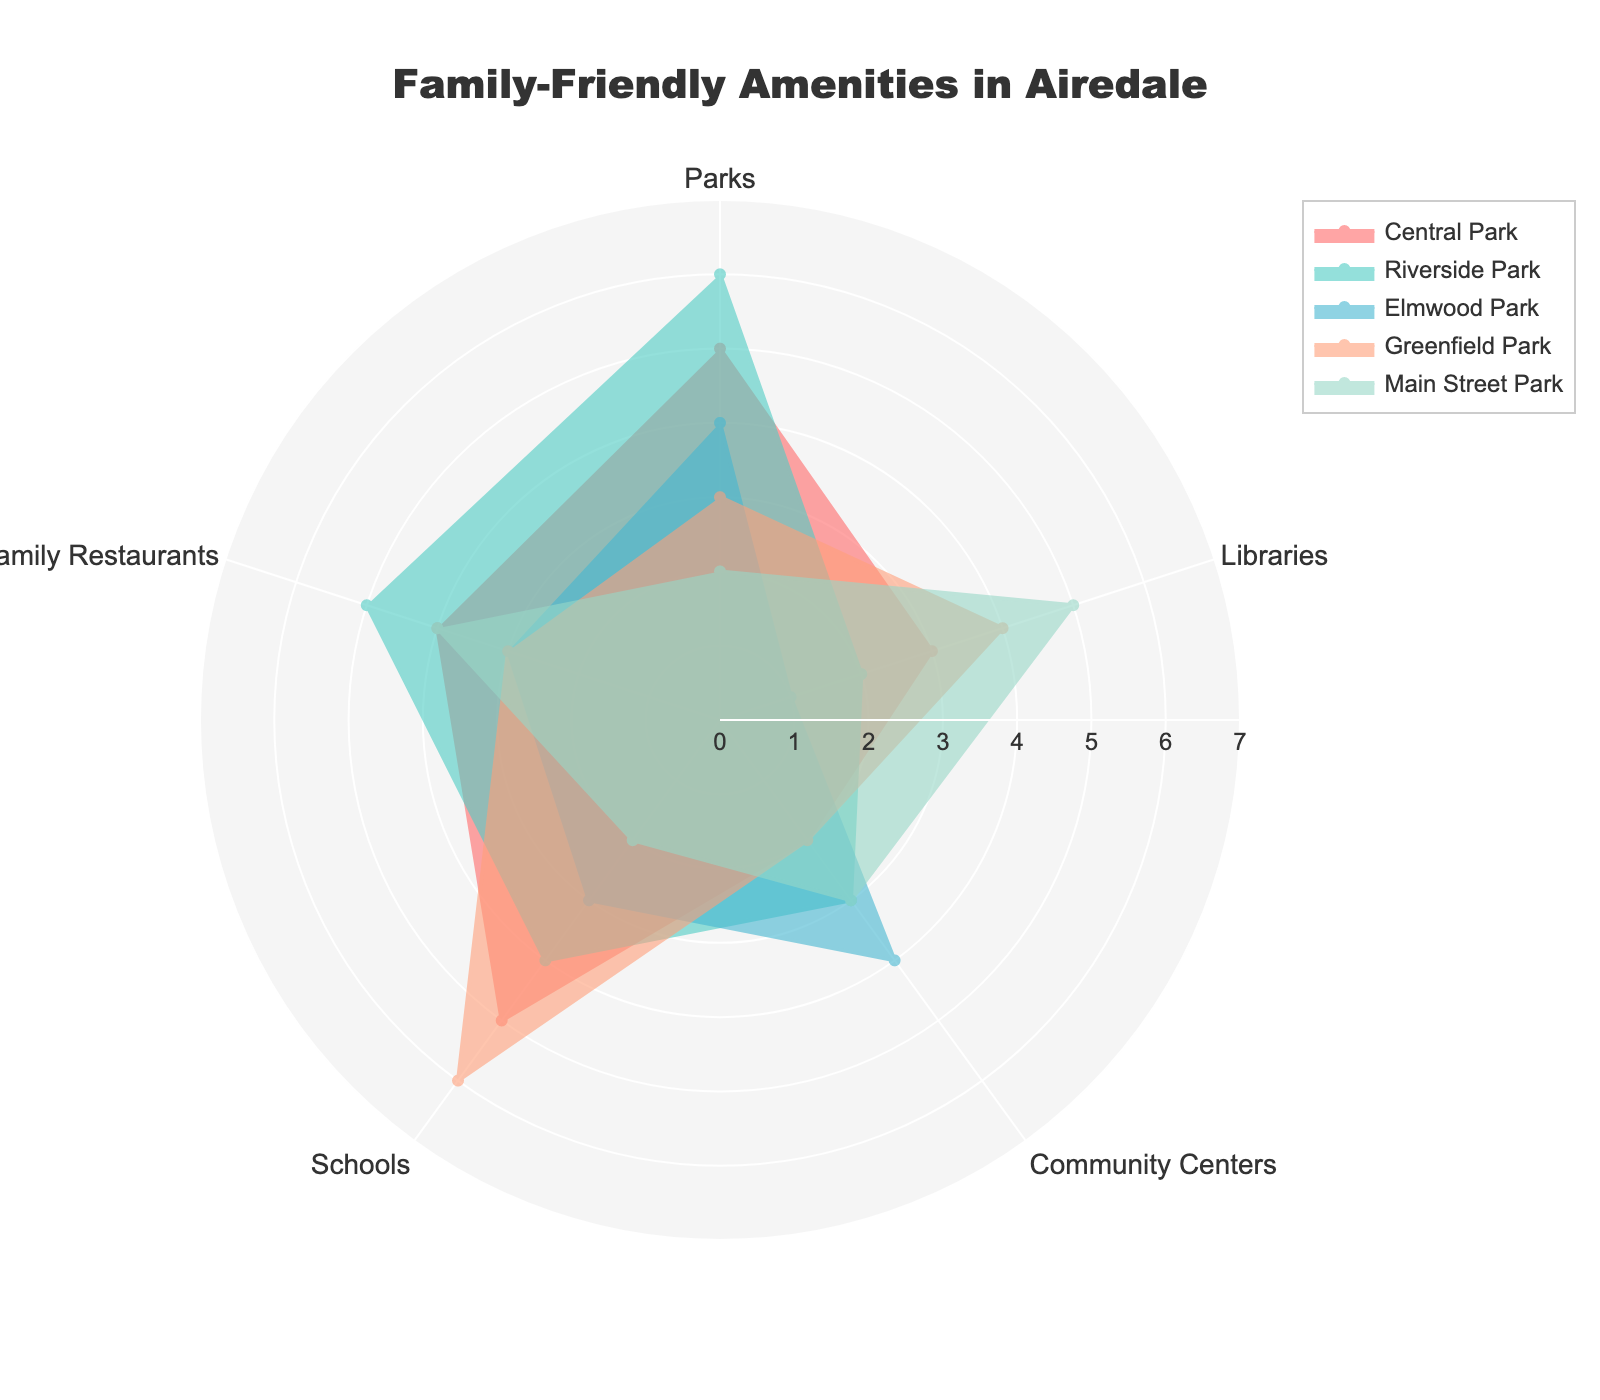Which category has the highest number of Parks? By looking at the radar chart, you can identify the line representing each category in the Parks section. Central Park, Riverside Park, and Elmwood Park have the highest values. Among these, Riverside Park has the peak at 6
Answer: Riverside Park Which Family Restaurant is rated the lowest in terms of amenities? Examine the radial lines for the Family Restaurants category in each sector. Each section's data point is easy to see, and the lowest value is 3 in Elmwood Park and Greenfield Park
Answer: Elmwood Park and Greenfield Park What is the total number of Libraries in Central Park and Main Street Park? Find the values for Libraries in Central Park and Main Street Park and sum them up: Central Park has 3, and Main Street Park has 5. Summing them gives 3 + 5 = 8
Answer: 8 Which category provides the greatest number of Schools? Identify the peak values within the Schools category across all entries. Greenfield Park stands out with the highest value at 6
Answer: Greenfield Park How do the number of Community Centers in Central Park and Elmwood Park compare? The radar chart shows each section's data point for Community Centers. Central Park has 2, while Elmwood Park has 4, thus Elmwood Park has more Community Centers
Answer: Elmwood Park What is the average number of Parks among all categories? Add the number of Parks in each category: 5 (Central Park) + 6 (Riverside Park) + 4 (Elmwood Park) + 3 (Greenfield Park) + 2 (Main Street Park) = 20. Divide by the number of categories (5), so the average is 20/5 = 4
Answer: 4 Which category scores the highest for Family Restaurants, and how many points more does it have compared to the lowest scorer? Examine the radar chart for Family Restaurants values. Riverside Park stands out with 5, and the lowest values are 3 in Elmwood Park and Greenfield Park. The difference here is 5 - 3 = 2
Answer: Riverside Park, 2 points What is the total amount of Community Centers in all categories combined? Add up the Community Centers' data points for each category: 2 (Central Park) + 3 (Riverside Park) + 4 (Elmwood Park) + 2 (Greenfield Park) + 3 (Main Street Park) = 14
Answer: 14 Which category has the most balanced distribution of amenities? To determine balance, assess each category's values for uniformity across Parks, Libraries, Community Centers, Schools, and Family Restaurants. Main Street Park is the most balanced with no standout extremes
Answer: Main Street Park 